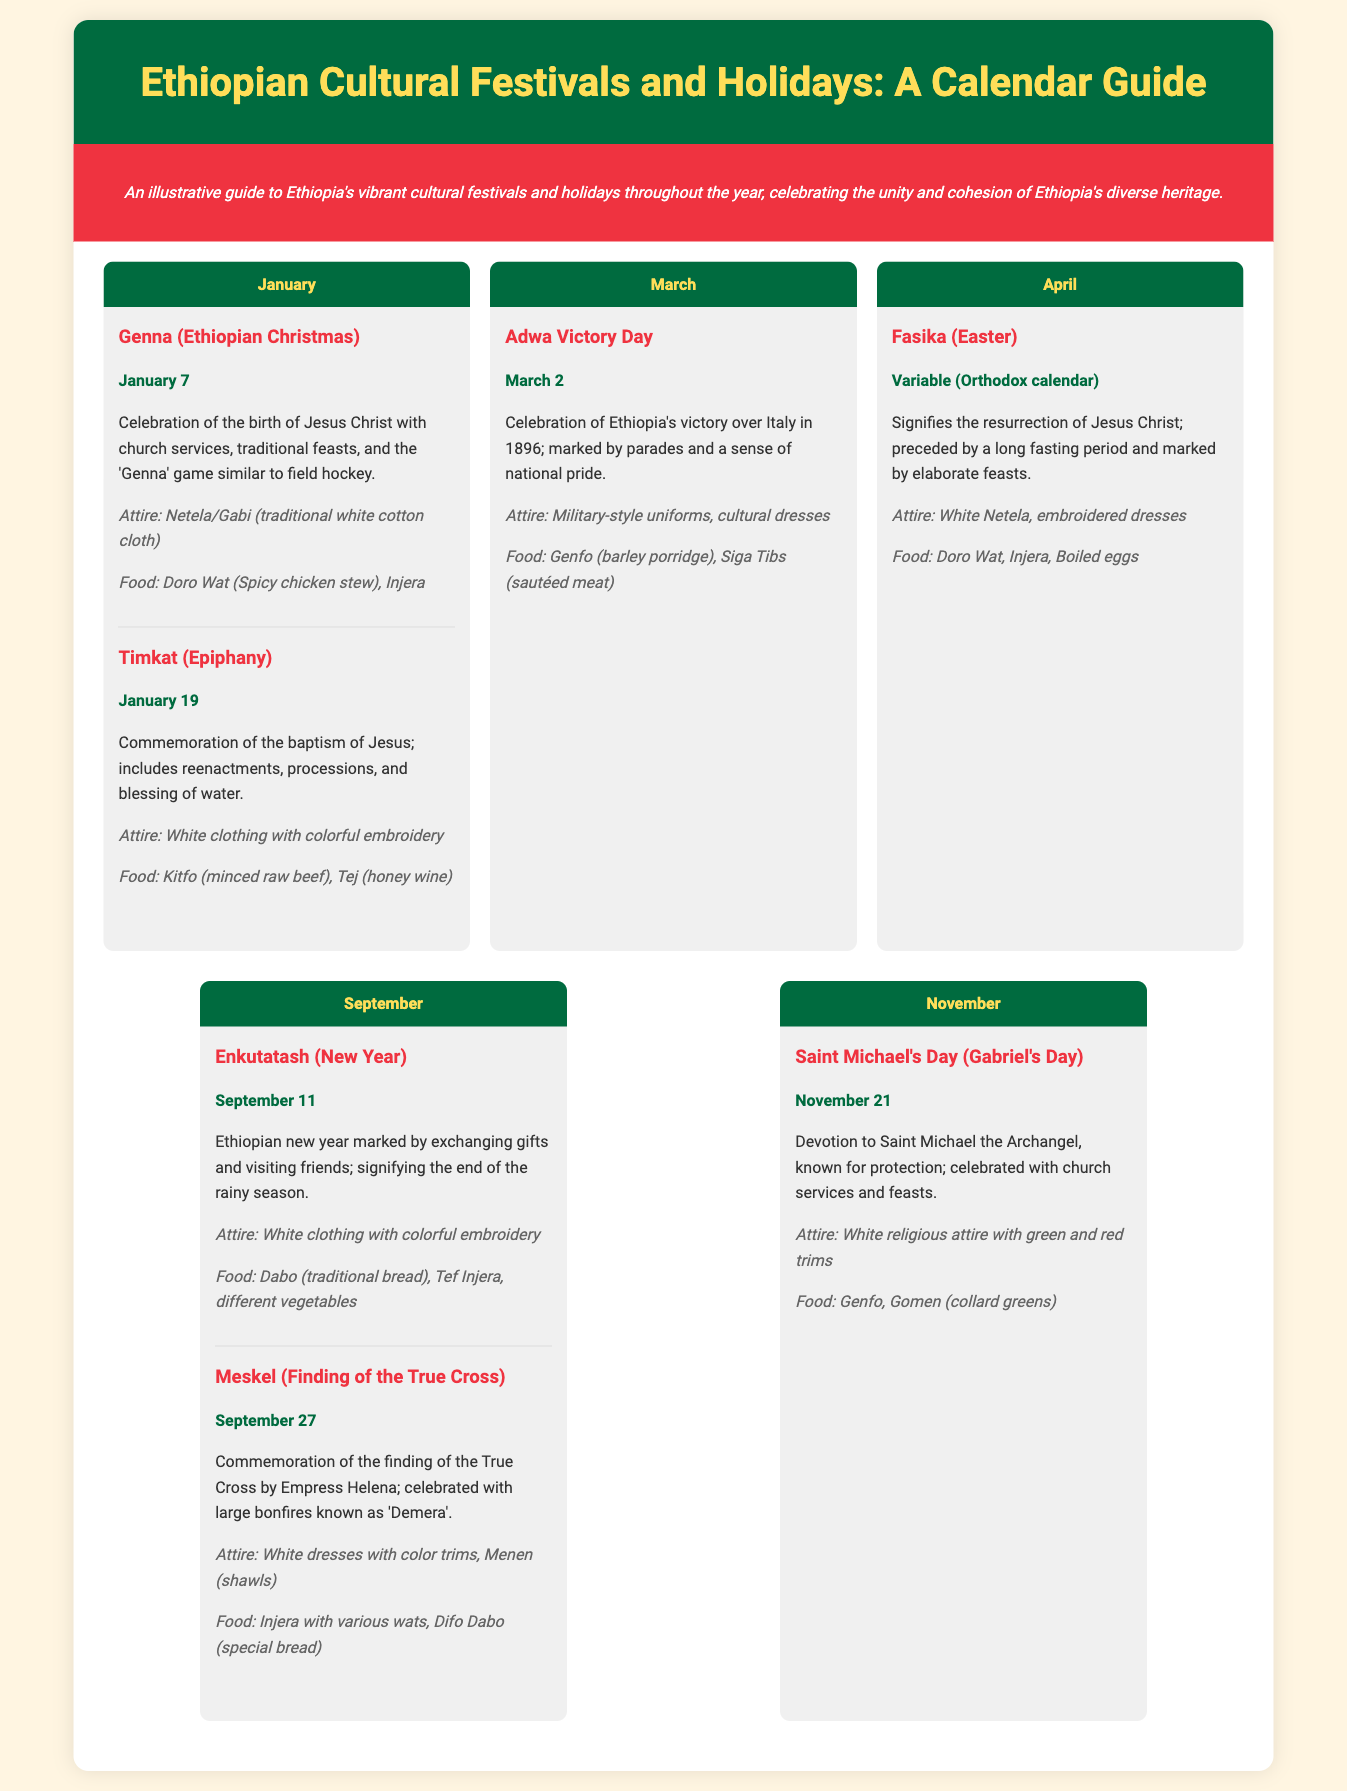What celebration occurs on January 7? The document states that on January 7, Genna (Ethiopian Christmas) is celebrated, which marks the birth of Jesus Christ.
Answer: Genna What food is typically eaten during Timkat? The description for Timkat indicates that Kitfo (minced raw beef) and Tej (honey wine) are traditional foods for this celebration.
Answer: Kitfo On which date is Meskel celebrated? According to the document, Meskel is celebrated on September 27 to commemorate the finding of the True Cross.
Answer: September 27 What is the significance of Enkutatash? Enkutatash marks the Ethiopian New Year, signifying the end of the rainy season and involves exchanging gifts and visiting friends.
Answer: New Year What attire is associated with Genna? The traditional attire worn during Genna is specified as Netela/Gabi, which is a traditional white cotton cloth.
Answer: Netela/Gabi How many major festivals are mentioned for the month of September? The document lists two major festivals in September: Enkutatash and Meskel.
Answer: Two What type of clothing is worn during Adwa Victory Day? The attire for Adwa Victory Day includes military-style uniforms and cultural dresses, as detailed in the document.
Answer: Military-style uniforms, cultural dresses What month is associated with Fasika? The document specifies that Fasika, which signifies the resurrection of Jesus Christ, takes place in April.
Answer: April 